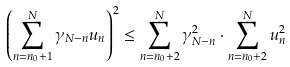<formula> <loc_0><loc_0><loc_500><loc_500>\left ( \sum _ { n = n _ { 0 } + 1 } ^ { N } \gamma _ { N - n } u _ { n } \right ) ^ { 2 } \leq \sum _ { n = n _ { 0 } + 2 } ^ { N } \gamma _ { N - n } ^ { 2 } \cdot \sum _ { n = n _ { 0 } + 2 } ^ { N } u _ { n } ^ { 2 }</formula> 